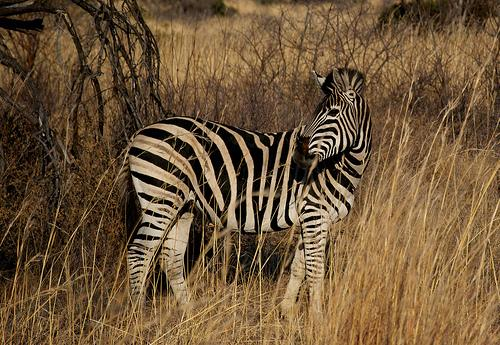Mention the key animal in the image along with its unique features. The image features a black and white zebra with a striped pattern, black nose, black eyes, white ears, long mane, short tail, and few stripes on its legs. Briefly describe the appearance of the zebra and the environment it is in. The zebra has a black and white striped pattern, black nose, and light legs, standing in the midst of long, brown, and wispy grass in a dry grassy field. Provide a brief overview of the scene depicted in the image. A zebra with black and white stripes, a black nose and eyes, and white ears is standing in the middle of a dry, brown grassy field with bare branches and brown leafless trees behind it. Create a quick summary of what the image showcases, keeping the zebra and the environment in focus. The image features a zebra with a striped pattern, black nose, and eyes, standing in a dry, grassy field amid long, brown grass and leafless trees. Provide a concise description of the image contents, including the zebra and environmental details. The image shows a zebra with black and white stripes, light legs, and a black nose, standing amidst dry, brown grass and leafless trees in a field. Explain the setting surrounding the zebra in the image. The zebra is surrounded by a field of tall, yellow, and dry grass, with brown leafless trees, bare branches and long brown grass near it. Give a synopsis of the image that includes the main animal and its environment. A zebra with black and white stripes, black eyes, and a black nose is seen standing in a dry grassy field with long, brown, and wispy grass and bare, leafless trees around it. Describe the background of the image with specific details about the vegetation. The background displays long, wispy, light brown grass, bare branches, brown leaflless trees, and a green tree in the top center of the image. Sum up the image by mentioning the main subject and the setting. The image portrays a zebra in a grassy field with long, brown, and wispy grass, leafless trees, and bare branches in the background. Outline the image, paying attention to the zebra's physical features and the grassy field. The zebra has a black and white striped pattern, black nose, and white ears, standing in a field of long, brown, and wispy grass with a shadow beneath it. 